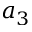<formula> <loc_0><loc_0><loc_500><loc_500>a _ { 3 }</formula> 